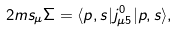<formula> <loc_0><loc_0><loc_500><loc_500>2 m s _ { \mu } \Sigma = \langle p , s | j ^ { 0 } _ { \mu 5 } | p , s \rangle ,</formula> 